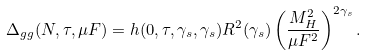<formula> <loc_0><loc_0><loc_500><loc_500>\Delta _ { g g } ( N , \tau , \mu F ) = h ( 0 , \tau , \gamma _ { s } , \gamma _ { s } ) R ^ { 2 } ( \gamma _ { s } ) \left ( \frac { M _ { H } ^ { 2 } } { \mu F ^ { 2 } } \right ) ^ { 2 \gamma _ { s } } .</formula> 